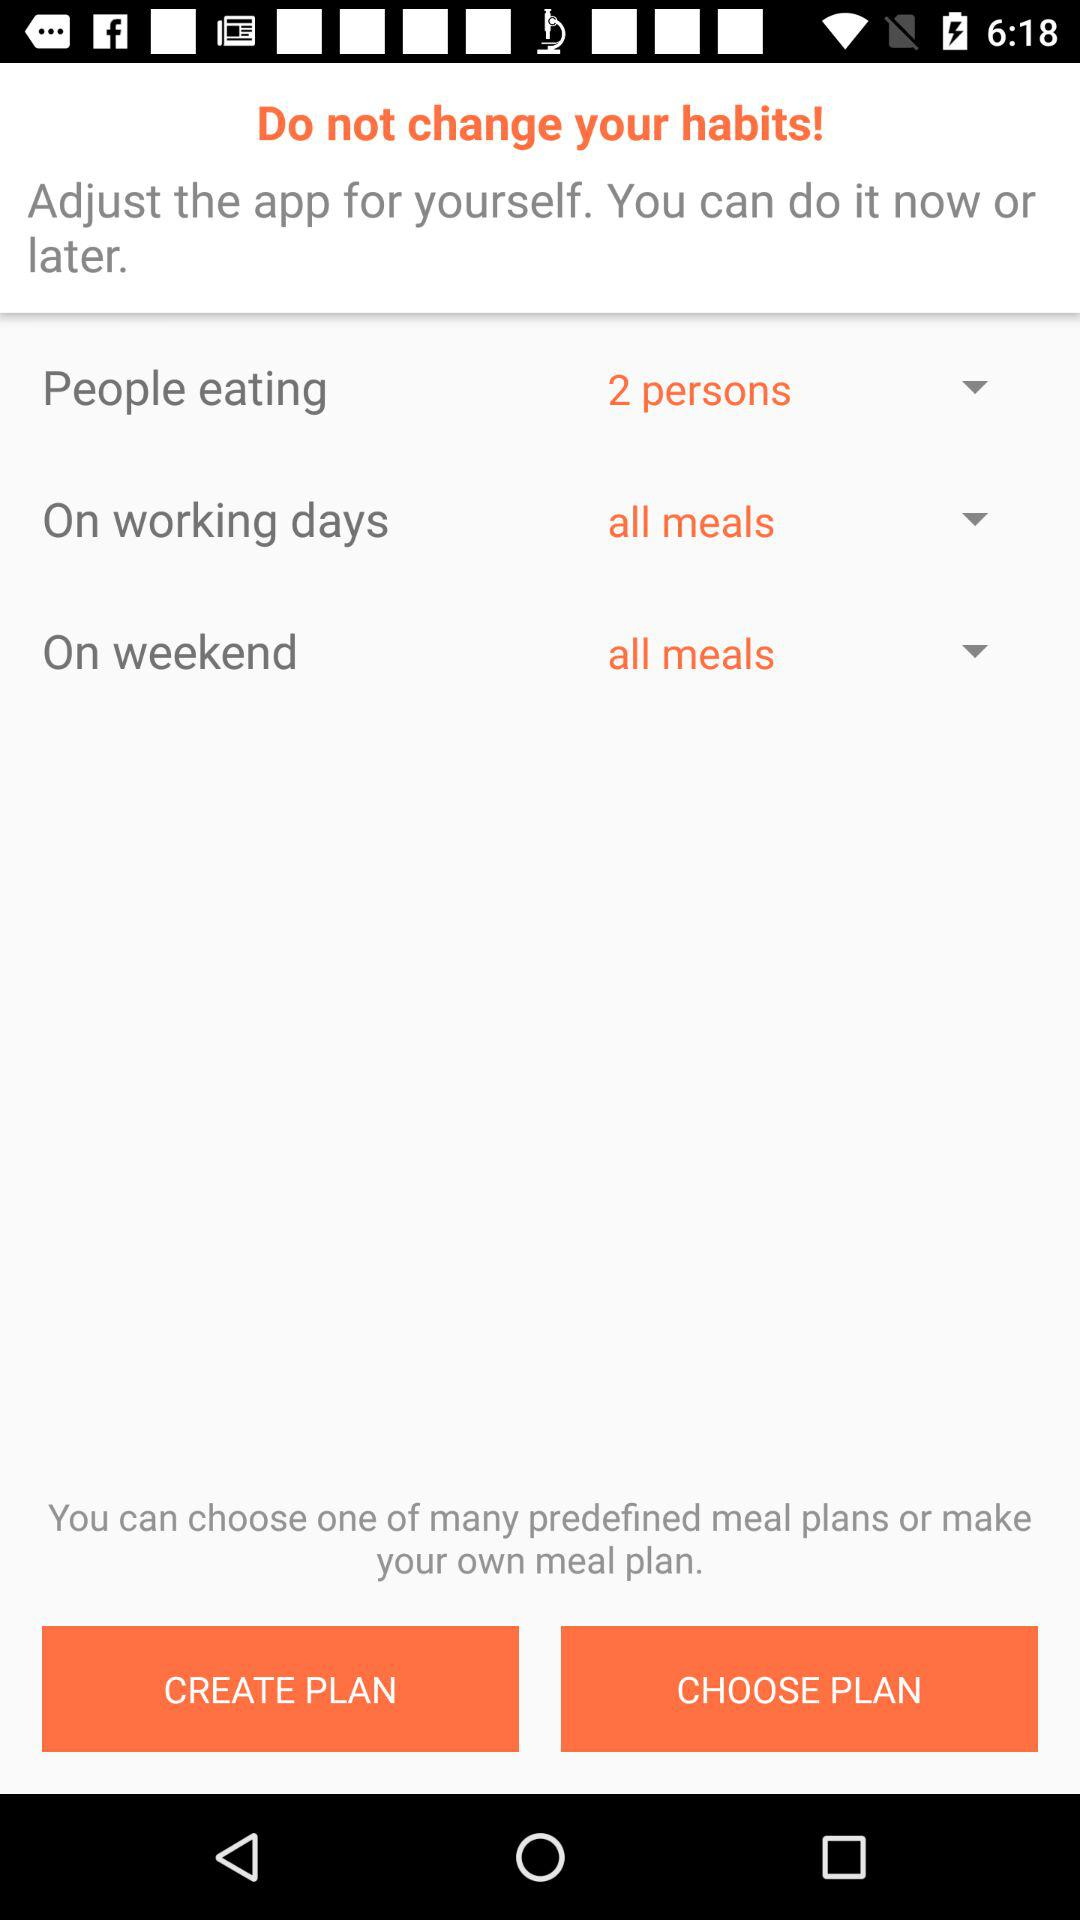What are the options given for a meal plan? The options given for a meal plan are "CREATE PLAN" and "CHOOSE PLAN". 